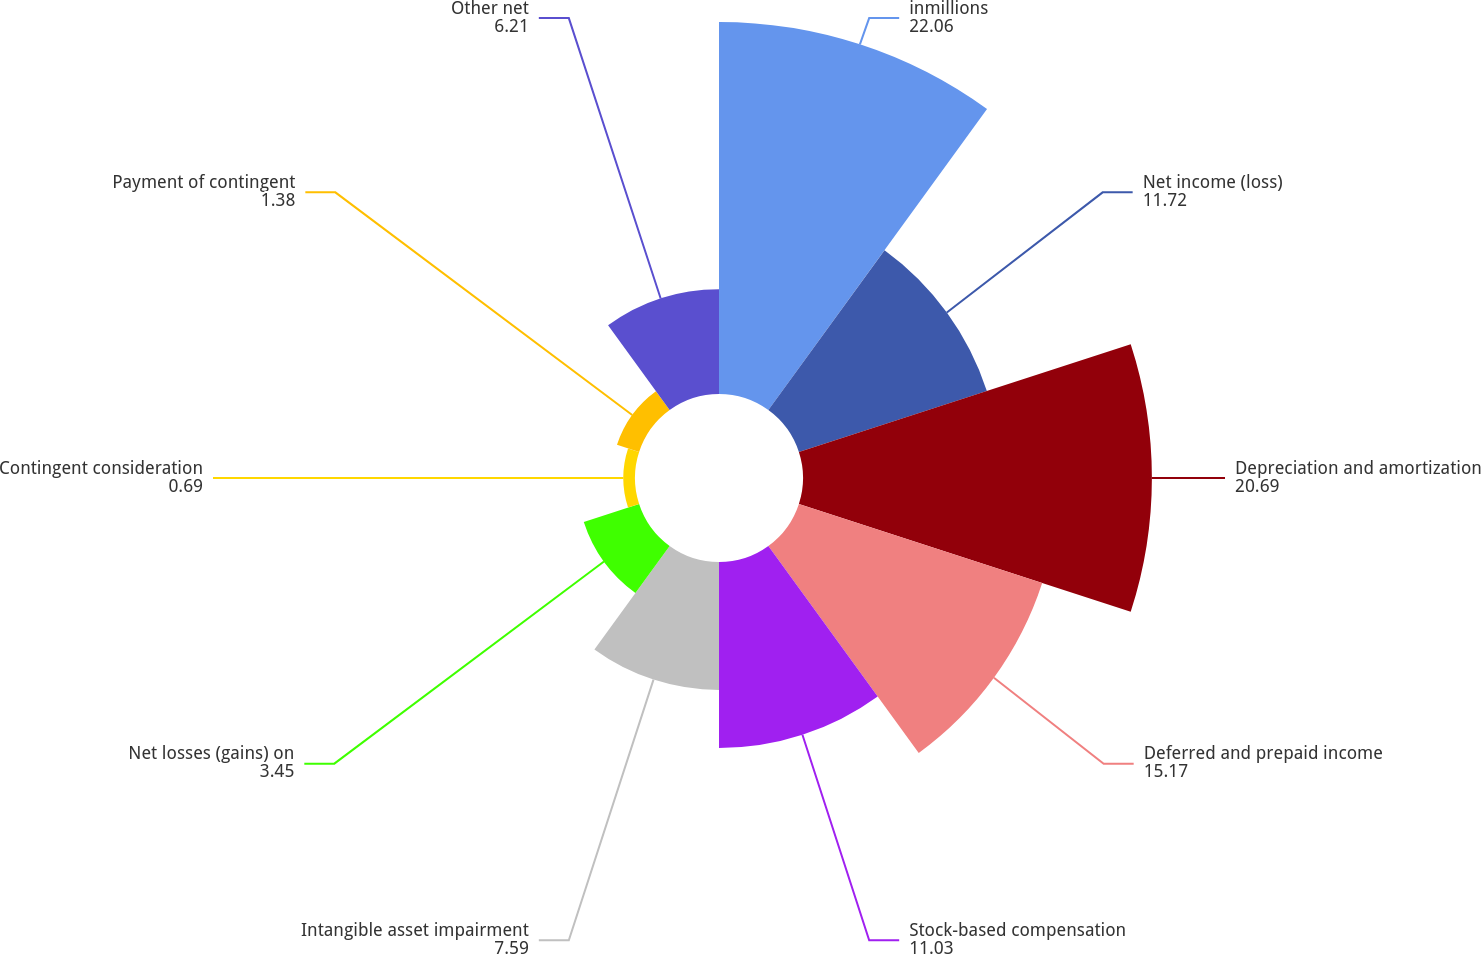Convert chart to OTSL. <chart><loc_0><loc_0><loc_500><loc_500><pie_chart><fcel>inmillions<fcel>Net income (loss)<fcel>Depreciation and amortization<fcel>Deferred and prepaid income<fcel>Stock-based compensation<fcel>Intangible asset impairment<fcel>Net losses (gains) on<fcel>Contingent consideration<fcel>Payment of contingent<fcel>Other net<nl><fcel>22.06%<fcel>11.72%<fcel>20.69%<fcel>15.17%<fcel>11.03%<fcel>7.59%<fcel>3.45%<fcel>0.69%<fcel>1.38%<fcel>6.21%<nl></chart> 